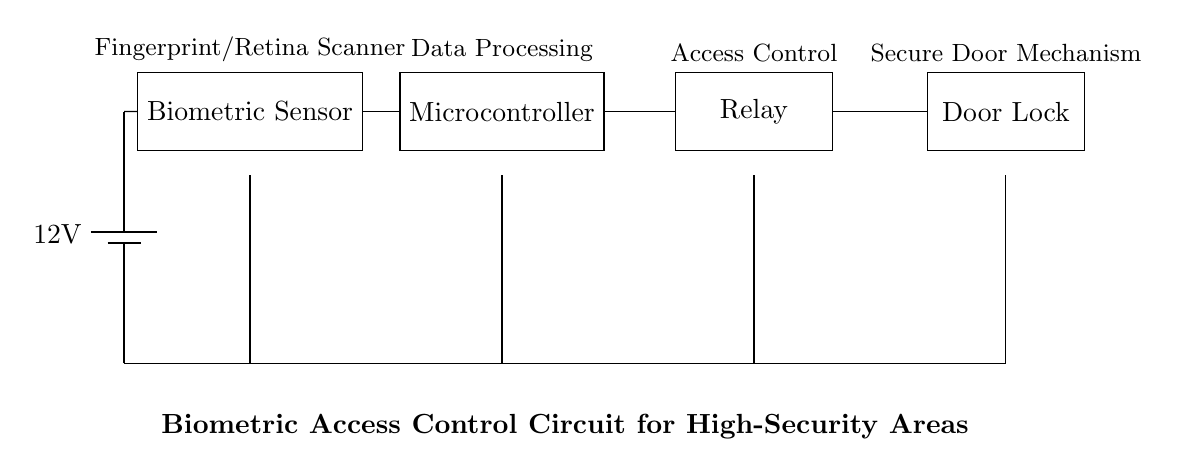What is the power supply voltage for this circuit? The power supply is represented by a battery in the circuit diagram, labeled with a voltage of 12 volts, which indicates the potential difference provided to the entire circuit.
Answer: 12 volts What is the role of the microcontroller in this circuit? The microcontroller connects to the biometric sensor and the relay, indicating its role in processing the data received from the sensor and generating the appropriate control signal for the relay to unlock the door.
Answer: Data processing Which component directly controls the door lock? The relay is directly connected to the door lock, serving as a switch that controls the power to the lock based on the microcontroller's output signal.
Answer: Relay What type of biometric sensor is used in this circuit? The circuit diagram specifically labels the sensor as a "Fingerprint/Retina Scanner," indicating its function and type, which is crucial for the access control mechanism.
Answer: Fingerprint/Retina Scanner How many components are connected to the biometric sensor? There are two components connected to the biometric sensor: the microcontroller and the power supply, indicating its interaction with both data processing and voltage supply.
Answer: Two What is the function of the relay in this circuit? The relay is labeled as "Access Control" and serves the function of switching the power to the door lock based on the command received from the microcontroller, ultimately controlling access.
Answer: Access control What does the ground connection indicate in this circuit? The ground connections serve as a reference point for the electrical circuit, ensuring all components operate with a common potential, which is crucial for stable operation and safety.
Answer: Common reference 